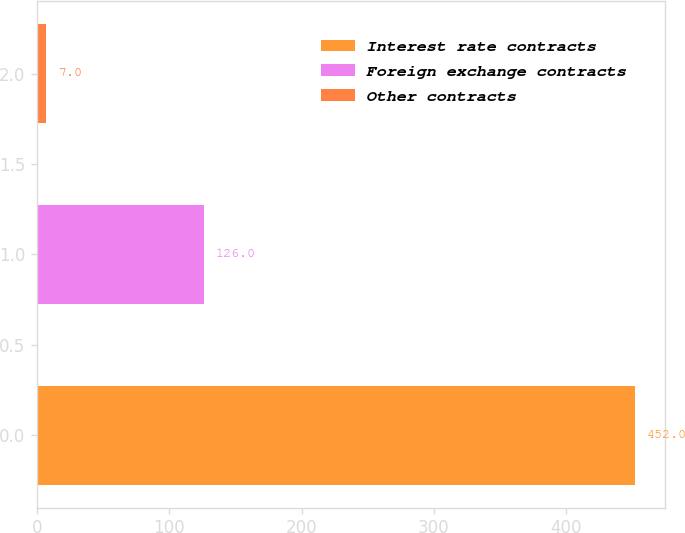<chart> <loc_0><loc_0><loc_500><loc_500><bar_chart><fcel>Interest rate contracts<fcel>Foreign exchange contracts<fcel>Other contracts<nl><fcel>452<fcel>126<fcel>7<nl></chart> 